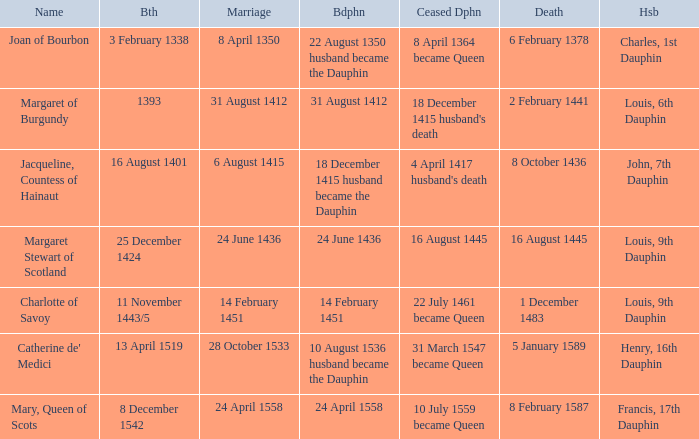When was became dauphine when birth is 1393? 31 August 1412. 